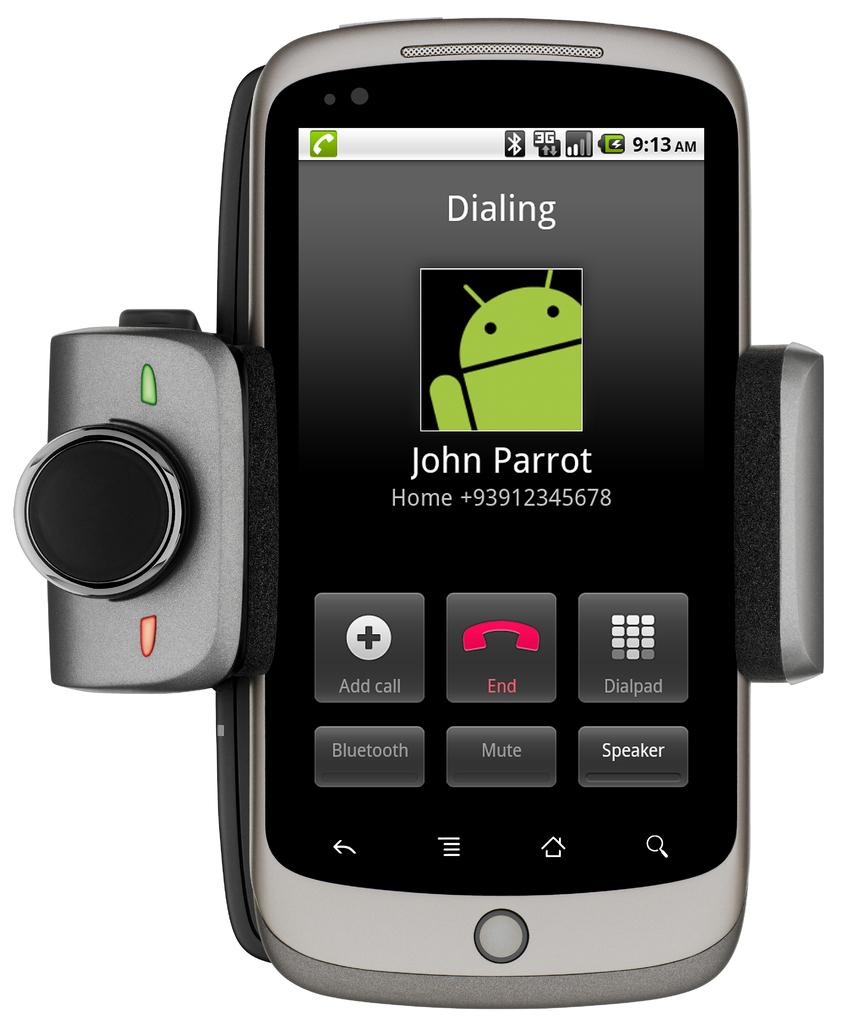What is the main subject of the image? There is a mobile in the image. What else can be seen in the image besides the mobile? There are some objects in the image. What is the color of the background in the image? The background of the image is white. Can you tell if the image has been altered or edited? Yes, the image appears to be an edited photo. What type of sock is being offered in the image? There is no sock present in the image. Can you describe the argument taking place between the objects in the image? There is no argument taking place between the objects in the image, as there are no objects that can engage in an argument. 